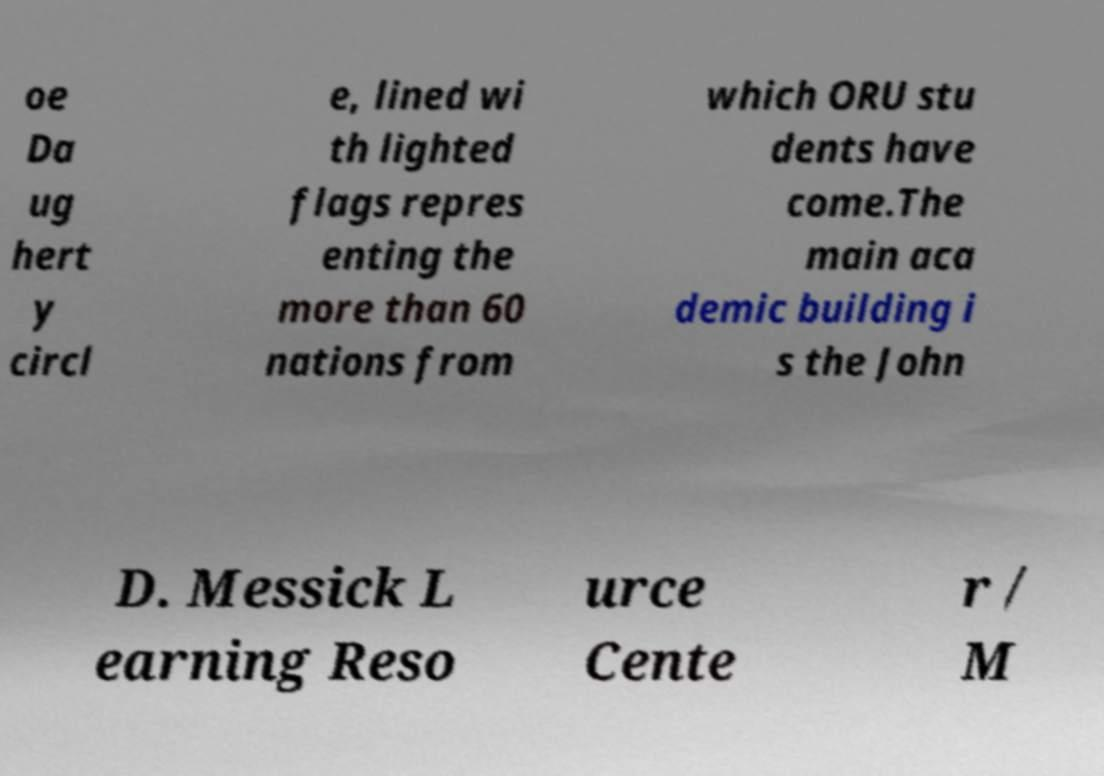Please identify and transcribe the text found in this image. oe Da ug hert y circl e, lined wi th lighted flags repres enting the more than 60 nations from which ORU stu dents have come.The main aca demic building i s the John D. Messick L earning Reso urce Cente r / M 